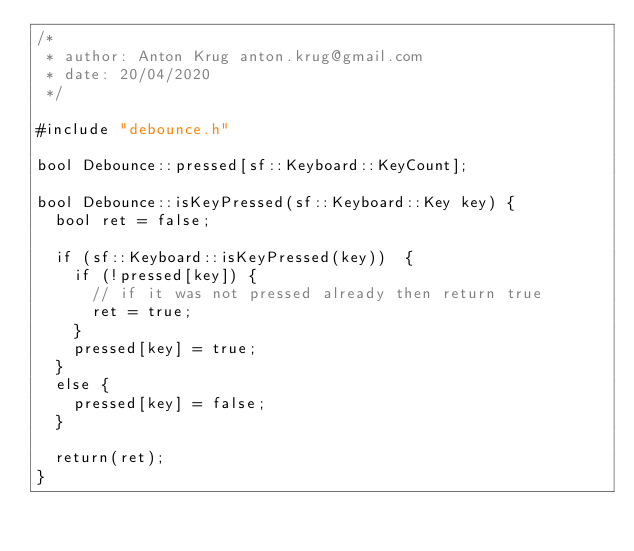<code> <loc_0><loc_0><loc_500><loc_500><_C++_>/*
 * author: Anton Krug anton.krug@gmail.com
 * date: 20/04/2020
 */

#include "debounce.h"

bool Debounce::pressed[sf::Keyboard::KeyCount];

bool Debounce::isKeyPressed(sf::Keyboard::Key key) {
  bool ret = false;

  if (sf::Keyboard::isKeyPressed(key))  {
    if (!pressed[key]) {
      // if it was not pressed already then return true
      ret = true;
    }
    pressed[key] = true;
  }
  else {
    pressed[key] = false;
  }

  return(ret);
}

</code> 